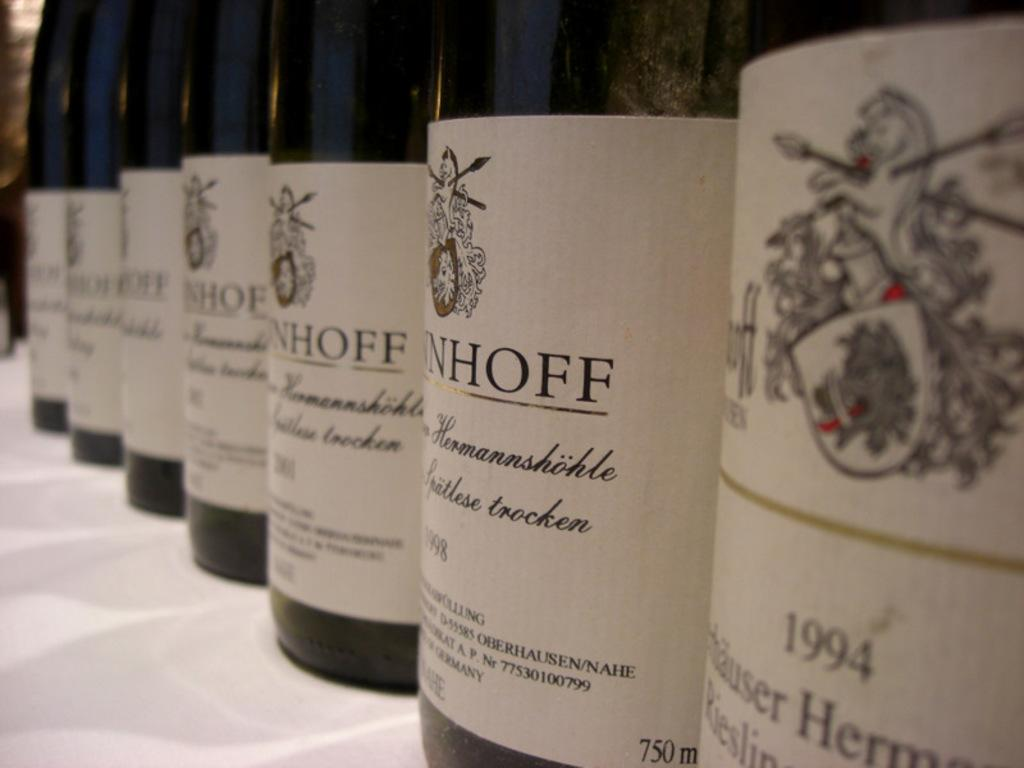Provide a one-sentence caption for the provided image. Many bottles of wine are lined up, including one of 1994 and another from 1998. 